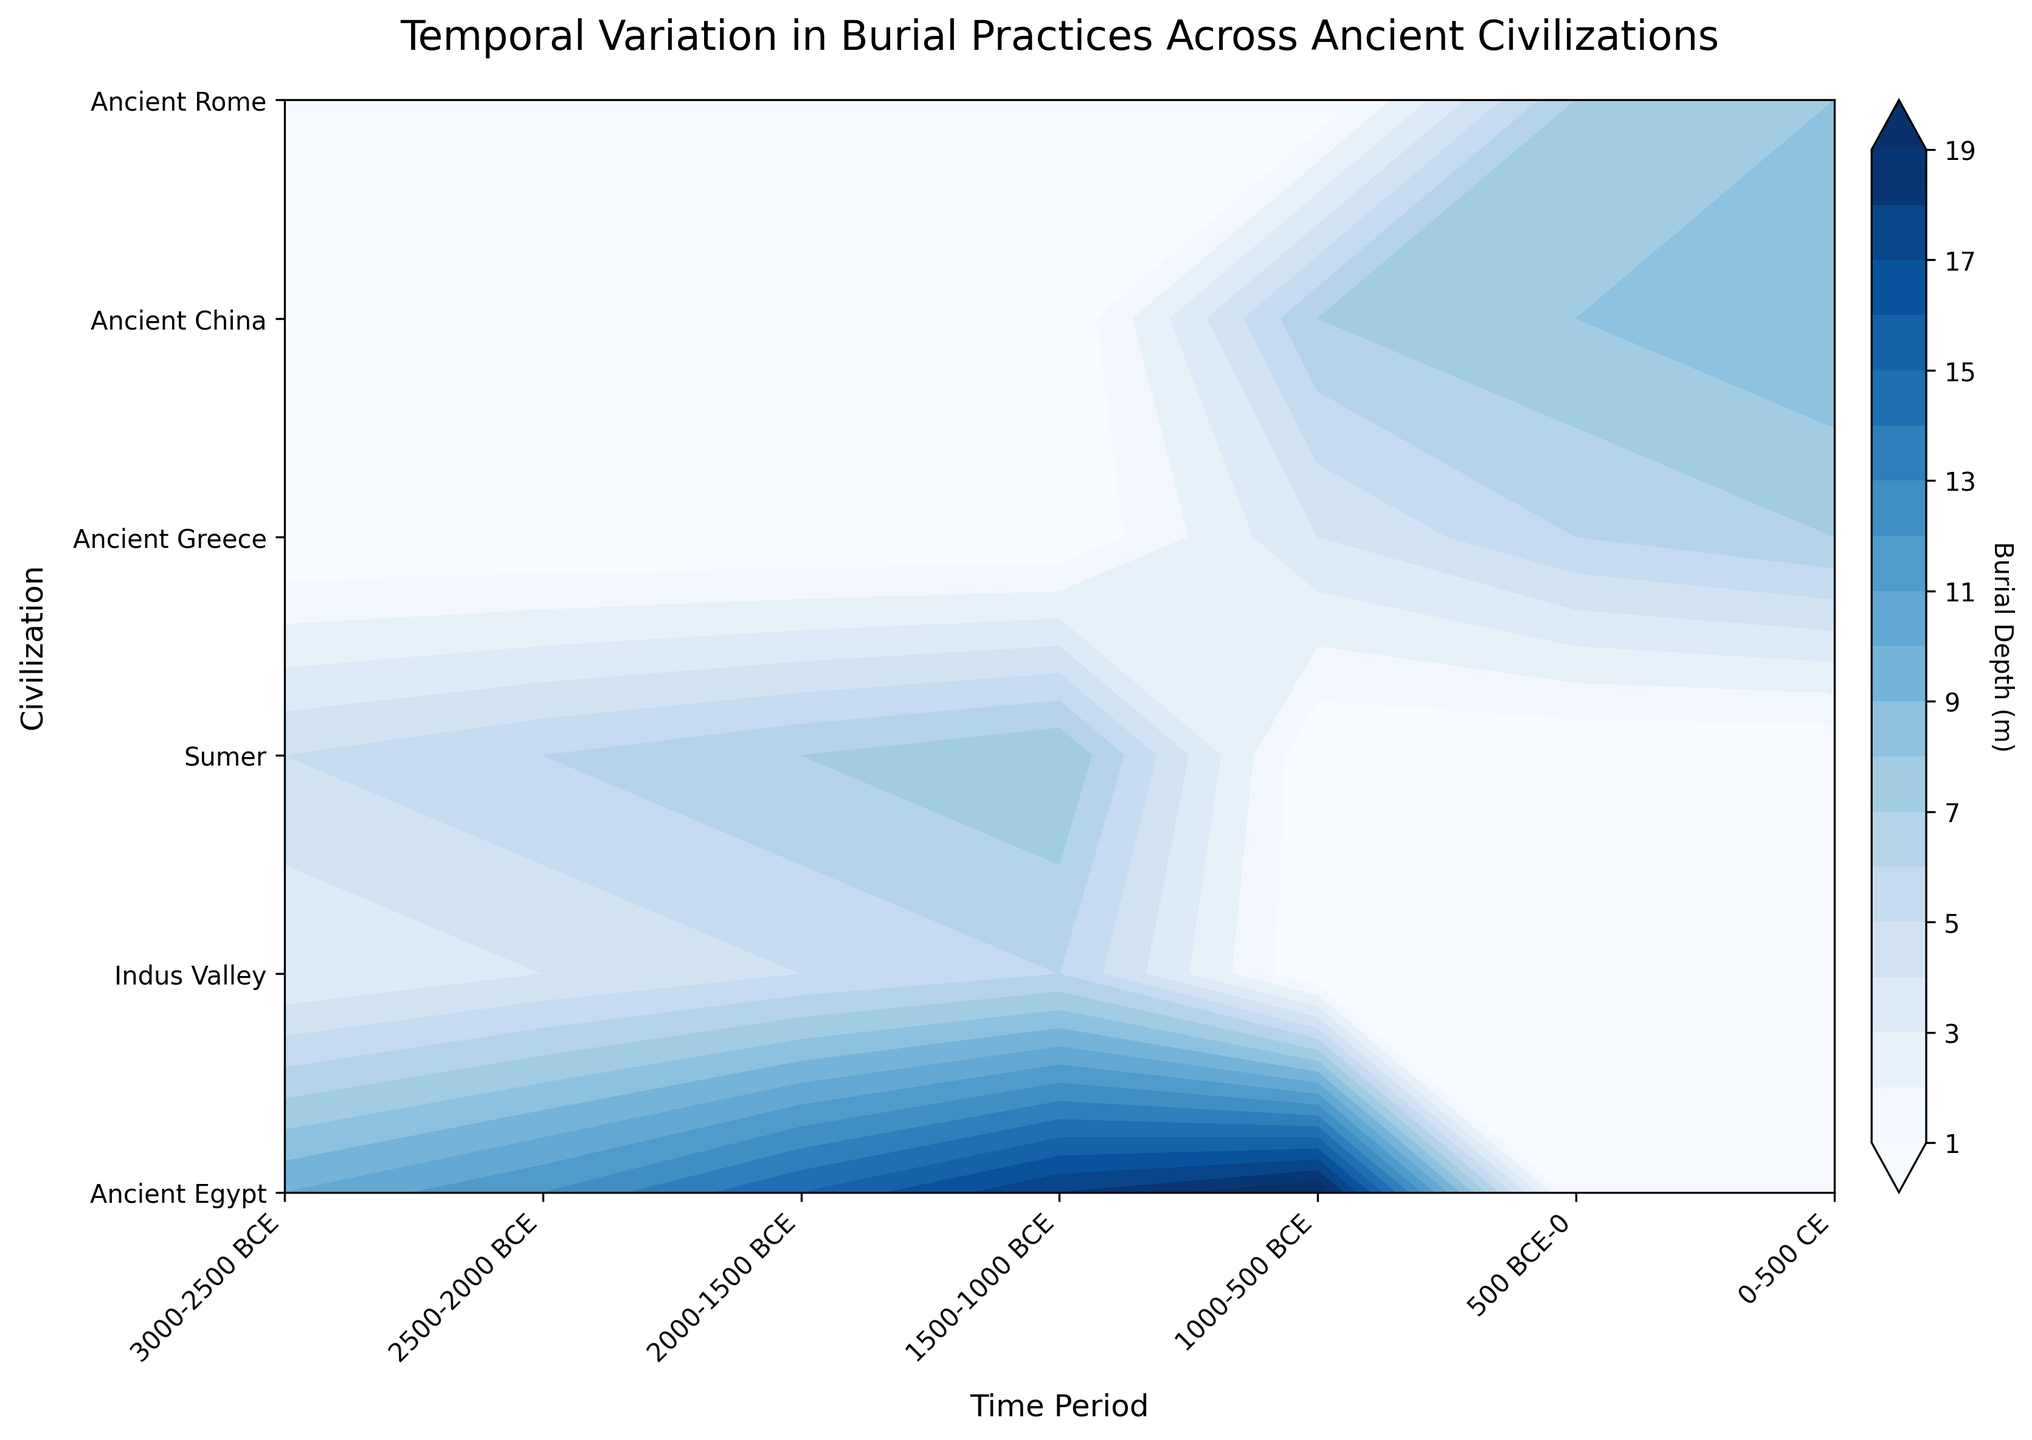How many unique time periods are represented in the plot? The x-axis of the plot shows the time periods. By counting the unique labels along the x-axis, we identify how many separate time periods are represented.
Answer: 7 Which civilization has the deepest burial depth in any time period? By examining the contour levels and referring to the y-axis, identify which civilization has the highest value for burial depth. Ancient Egypt has the highest burial depth around 1000-500 BCE.
Answer: Ancient Egypt What is the range of burial depth for the Indus Valley civilization? Find the lowest and highest contours related to Indus Valley across all time periods and determine the range. The lowest depth is 3 and the highest is 6. So, the range is 6 - 3 = 3.
Answer: 3 During 1000-500 BCE, which civilization had the least burial depth? Look at the contour lines and values for the specific time period (1000-500 BCE) and identify which civilization has the lowest value. Based on the figure, Ancient Greece has a burial depth value of 4, which is the lowest.
Answer: Ancient Greece By how much did the burial depth change for Ancient Egypt between 3000-2500 BCE and 1000-500 BCE? Locate the burial depth values for Ancient Egypt for both indicated periods: 10 for 3000-2500 BCE and 20 for 1000-500 BCE. Calculate the difference: 20 - 10 = 10 meters.
Answer: 10 meters Which two civilizations have the most similar patterns in burial depth across all time periods? Analyze the contour values over time for all civilizations. Ancient China and Sumer display relatively gradual increases in burial depth values over time and lack extreme differences like other civilizations.
Answer: Sumer, Ancient China What is the overall trend in burial depths for Ancient Egypt from 3000-2500 BCE to 0-500 CE? Observe the change in burial depths specific to Ancient Egypt over the plotted timeframe. The contours show a consistent increase from 10 to 20 meters from 3000-2500 BCE to 0-500 CE.
Answer: Increasing Which civilization shows the most significant change in burial depth between consecutive time periods? Compare the burial depth changes between each subsequent period for all civilizations. Ancient Egypt shows the most notable variation, particularly between the earliest (3000-2500 BCE) and latest (0-500 CE) periods from 10 to 20 meters.
Answer: Ancient Egypt What is the shallowest burial depth observed in any civilization and time period? Identify the lowest burial depth value in the plot. The contour indicates that the lowest value is around 3 meters for the Indus Valley civilization during 3000-2500 BCE.
Answer: 3 meters How does the burial depth for Ancient Rome compare between 500 BCE-0 and 0-500 CE? Observe the contours for Ancient Rome for the specified periods: 7 meters for 500 BCE-0 and 8 meters for 0-500 CE. The depth increased by 1 meter between these periods.
Answer: Increased by 1 meter 